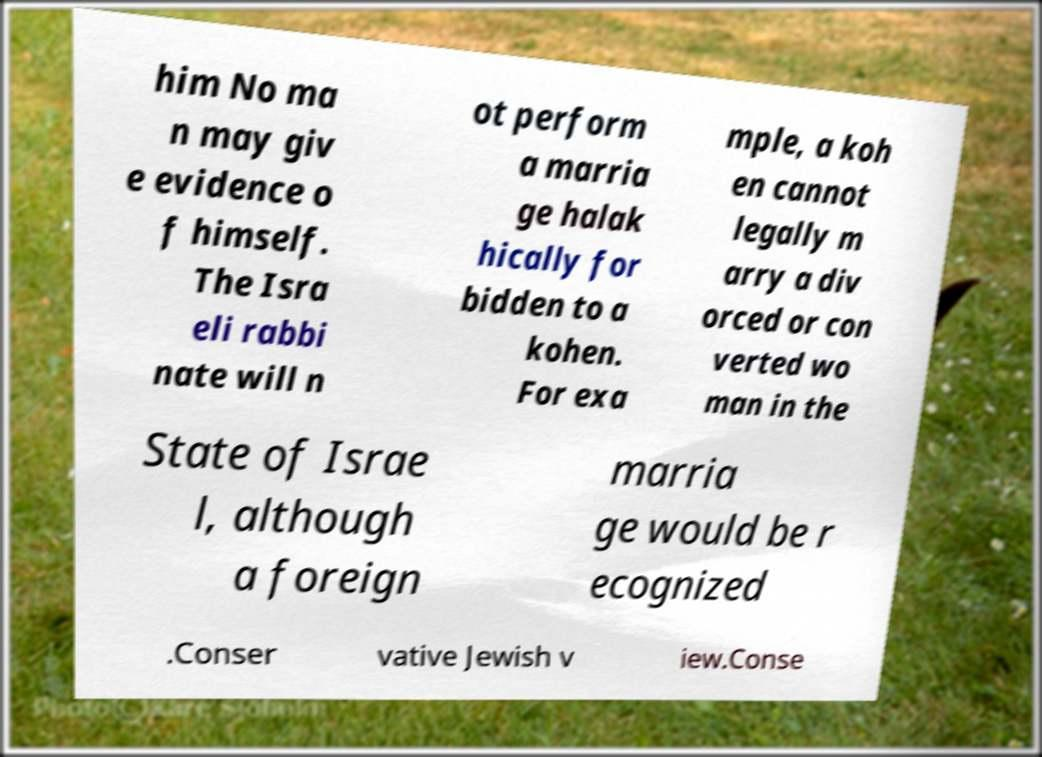Could you assist in decoding the text presented in this image and type it out clearly? him No ma n may giv e evidence o f himself. The Isra eli rabbi nate will n ot perform a marria ge halak hically for bidden to a kohen. For exa mple, a koh en cannot legally m arry a div orced or con verted wo man in the State of Israe l, although a foreign marria ge would be r ecognized .Conser vative Jewish v iew.Conse 